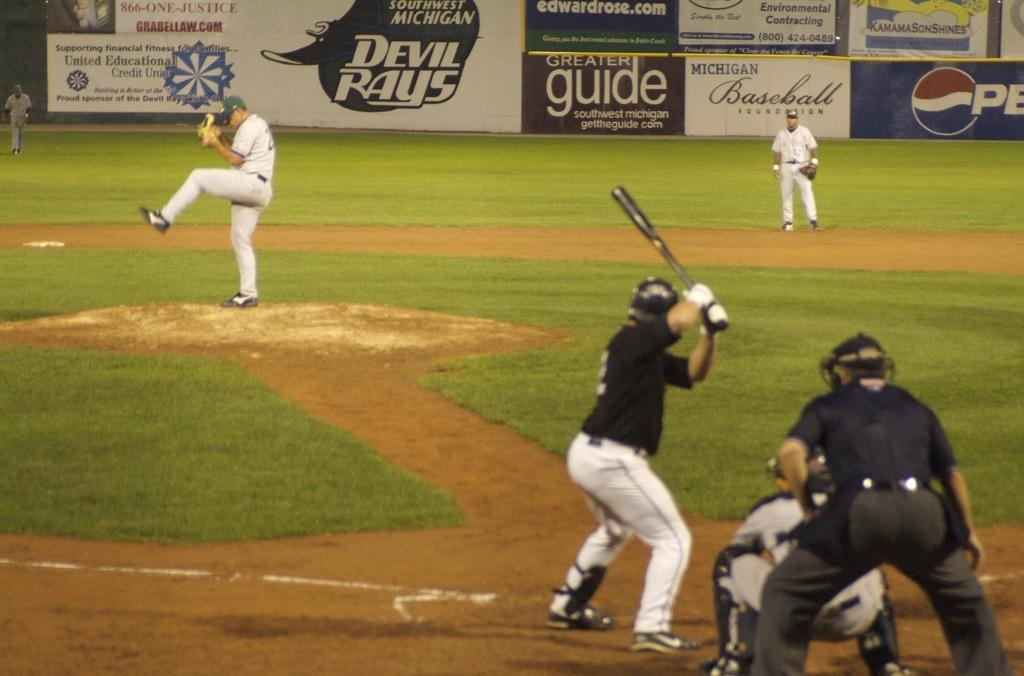<image>
Describe the image concisely. A baseball game is being played at a stadium that has an advertisement for Pepsi. 